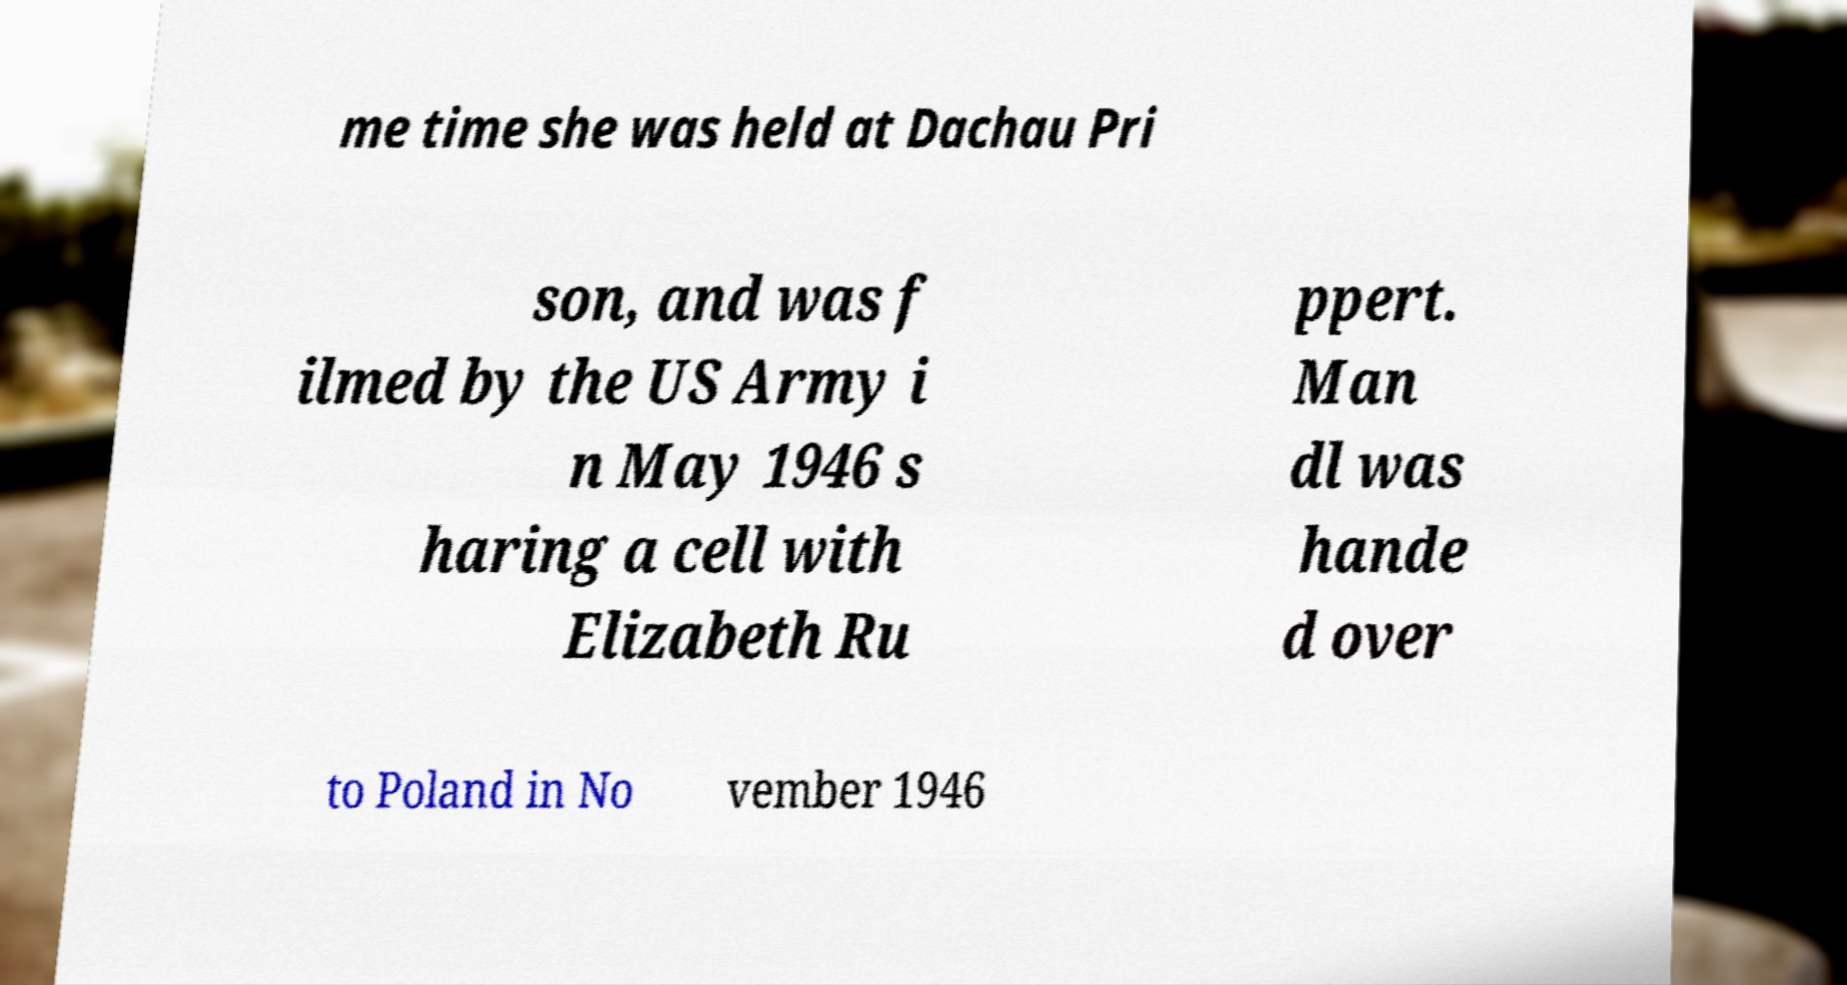I need the written content from this picture converted into text. Can you do that? me time she was held at Dachau Pri son, and was f ilmed by the US Army i n May 1946 s haring a cell with Elizabeth Ru ppert. Man dl was hande d over to Poland in No vember 1946 